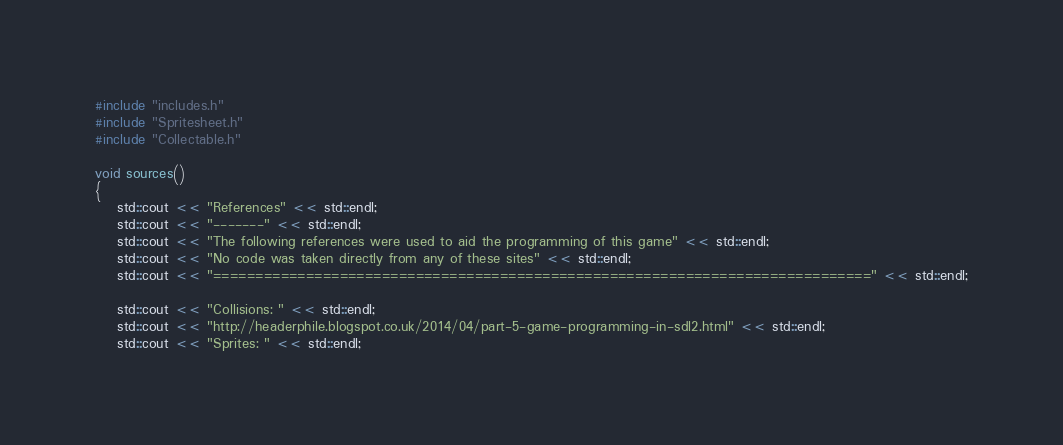<code> <loc_0><loc_0><loc_500><loc_500><_C++_>#include "includes.h"
#include "Spritesheet.h"
#include "Collectable.h"

void sources()
{
	std::cout << "References" << std::endl;
	std::cout << "-------" << std::endl;
	std::cout << "The following references were used to aid the programming of this game" << std::endl;
	std::cout << "No code was taken directly from any of these sites" << std::endl;
	std::cout << "==============================================================================" << std::endl;

	std::cout << "Collisions: " << std::endl; 
	std::cout << "http://headerphile.blogspot.co.uk/2014/04/part-5-game-programming-in-sdl2.html" << std::endl;
	std::cout << "Sprites: " << std::endl; </code> 